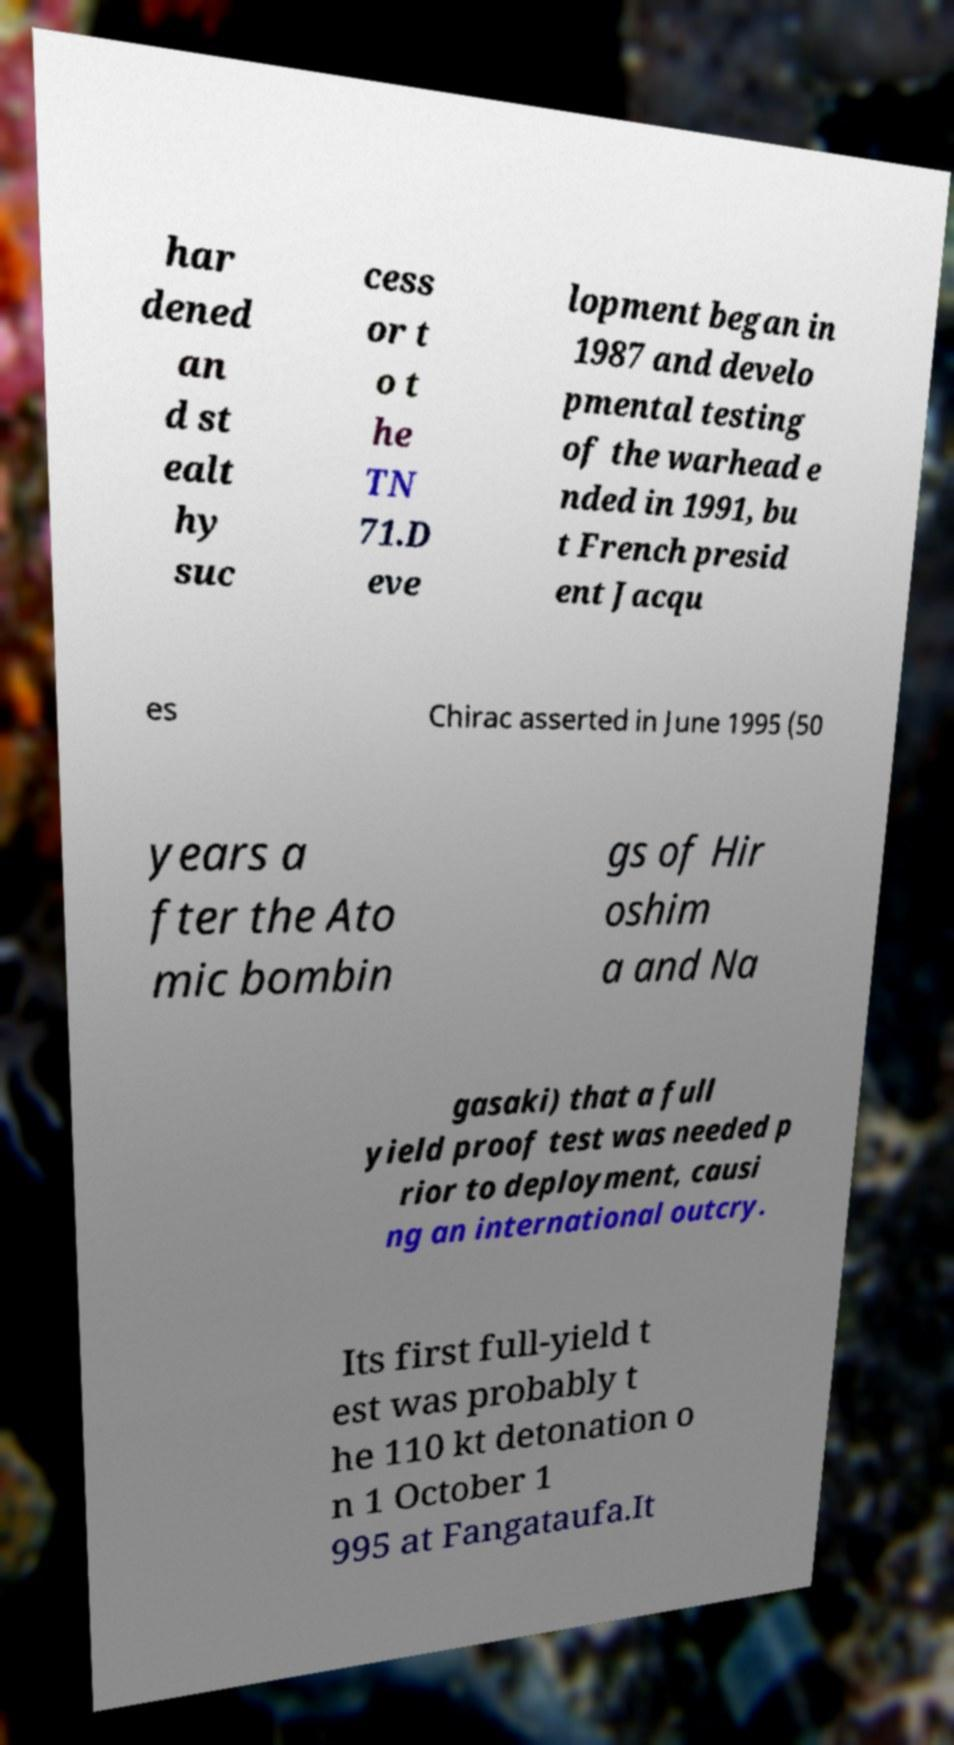I need the written content from this picture converted into text. Can you do that? har dened an d st ealt hy suc cess or t o t he TN 71.D eve lopment began in 1987 and develo pmental testing of the warhead e nded in 1991, bu t French presid ent Jacqu es Chirac asserted in June 1995 (50 years a fter the Ato mic bombin gs of Hir oshim a and Na gasaki) that a full yield proof test was needed p rior to deployment, causi ng an international outcry. Its first full-yield t est was probably t he 110 kt detonation o n 1 October 1 995 at Fangataufa.It 